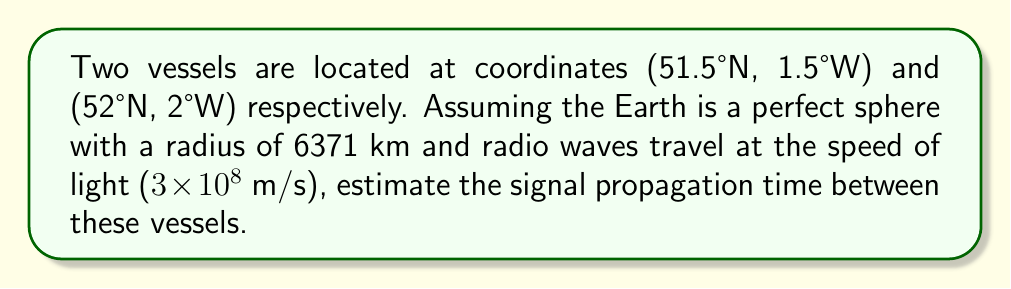Can you answer this question? To solve this problem, we'll follow these steps:

1) Calculate the great circle distance between the two points using the Haversine formula:

   $$a = \sin^2(\frac{\Delta\phi}{2}) + \cos\phi_1 \cos\phi_2 \sin^2(\frac{\Delta\lambda}{2})$$
   $$c = 2 \atan2(\sqrt{a}, \sqrt{1-a})$$
   $$d = Rc$$

   Where:
   $\phi$ is latitude, $\lambda$ is longitude, $R$ is Earth's radius

2) Convert coordinates to radians:
   (51.5°N, 1.5°W) → (0.8988 rad, -0.0262 rad)
   (52°N, 2°W) → (0.9076 rad, -0.0349 rad)

3) Apply the formula:
   $$a = \sin^2(\frac{0.9076 - 0.8988}{2}) + \cos(0.8988) \cos(0.9076) \sin^2(\frac{-0.0349 - (-0.0262)}{2})$$
   $$a = 2.3656 \times 10^{-5}$$

   $$c = 2 \atan2(\sqrt{2.3656 \times 10^{-5}}, \sqrt{1-2.3656 \times 10^{-5}}) = 0.0097$$

   $$d = 6371 \times 0.0097 = 61.80 \text{ km}$$

4) Calculate propagation time:
   $$t = \frac{d}{v} = \frac{61.80 \times 10^3}{3 \times 10^8} = 2.06 \times 10^{-4} \text{ seconds}$$
Answer: 206 microseconds 